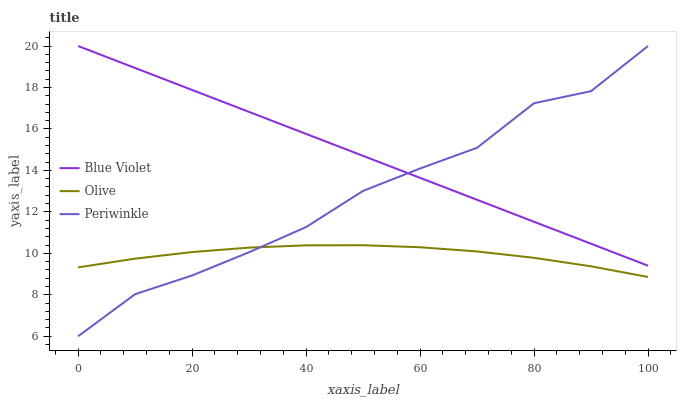Does Olive have the minimum area under the curve?
Answer yes or no. Yes. Does Blue Violet have the maximum area under the curve?
Answer yes or no. Yes. Does Periwinkle have the minimum area under the curve?
Answer yes or no. No. Does Periwinkle have the maximum area under the curve?
Answer yes or no. No. Is Blue Violet the smoothest?
Answer yes or no. Yes. Is Periwinkle the roughest?
Answer yes or no. Yes. Is Periwinkle the smoothest?
Answer yes or no. No. Is Blue Violet the roughest?
Answer yes or no. No. Does Periwinkle have the lowest value?
Answer yes or no. Yes. Does Blue Violet have the lowest value?
Answer yes or no. No. Does Blue Violet have the highest value?
Answer yes or no. Yes. Is Olive less than Blue Violet?
Answer yes or no. Yes. Is Blue Violet greater than Olive?
Answer yes or no. Yes. Does Periwinkle intersect Olive?
Answer yes or no. Yes. Is Periwinkle less than Olive?
Answer yes or no. No. Is Periwinkle greater than Olive?
Answer yes or no. No. Does Olive intersect Blue Violet?
Answer yes or no. No. 